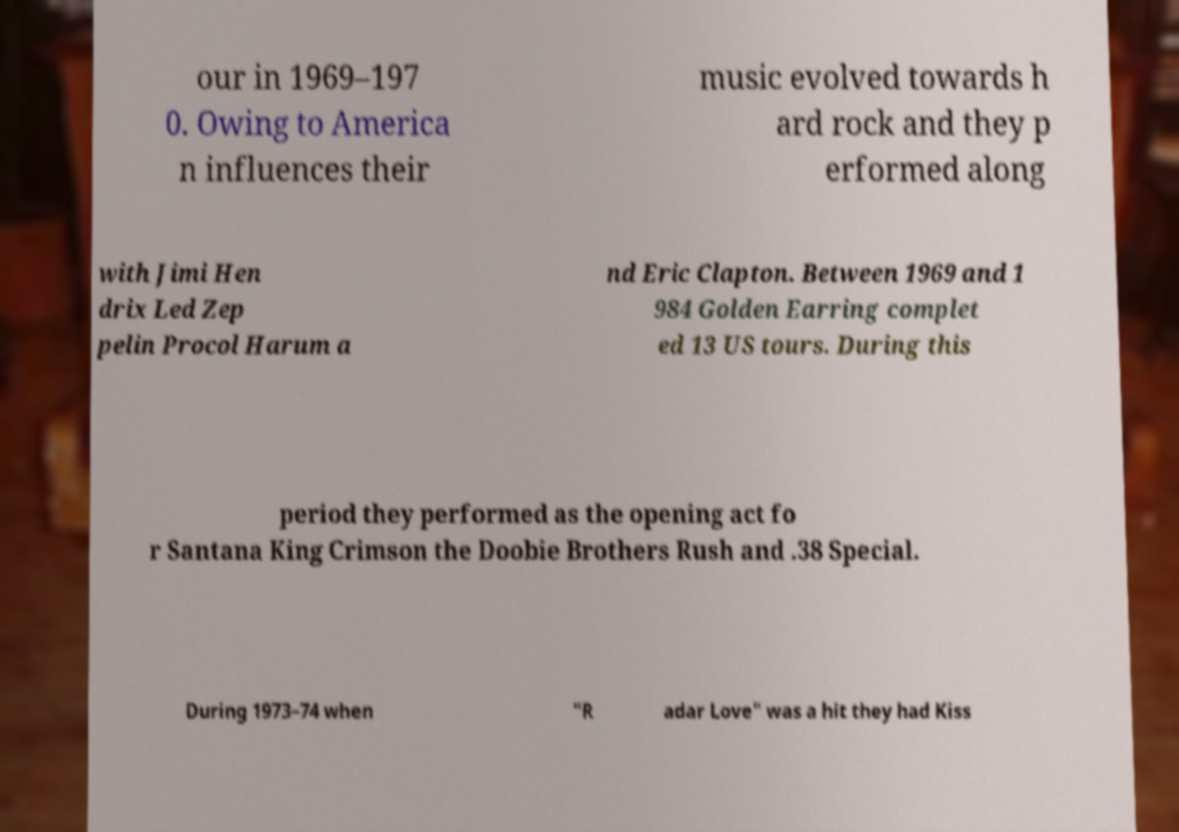There's text embedded in this image that I need extracted. Can you transcribe it verbatim? our in 1969–197 0. Owing to America n influences their music evolved towards h ard rock and they p erformed along with Jimi Hen drix Led Zep pelin Procol Harum a nd Eric Clapton. Between 1969 and 1 984 Golden Earring complet ed 13 US tours. During this period they performed as the opening act fo r Santana King Crimson the Doobie Brothers Rush and .38 Special. During 1973–74 when "R adar Love" was a hit they had Kiss 